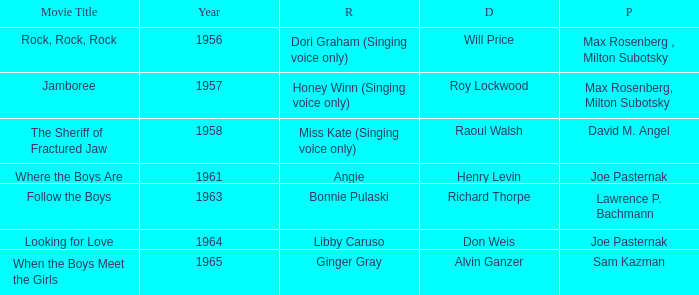Who were the producers in 1961? Joe Pasternak. 